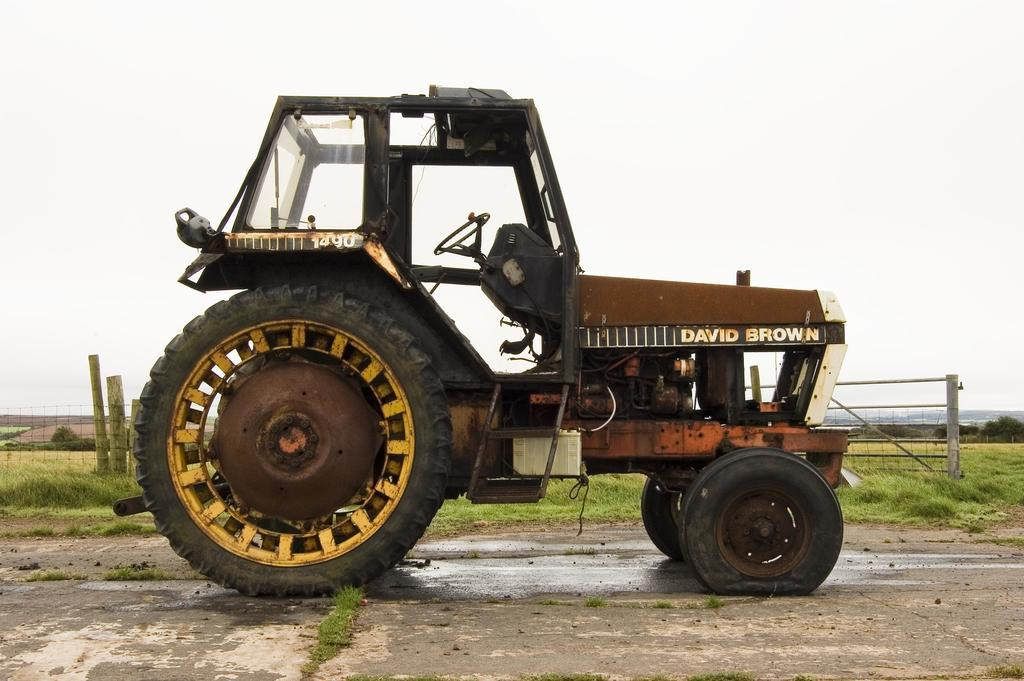What is the main subject in the middle of the image? There is a vehicle in the middle of the image. What can be seen in the background of the image? There is a mesh, wooden logs, grass, trees, and the sky visible in the background of the image. How many lizards are sitting on the can in the image? There are no lizards or cans present in the image. What type of rat can be seen interacting with the wooden logs in the image? There are no rats present in the image; only the vehicle, mesh, wooden logs, grass, trees, and sky are visible. 